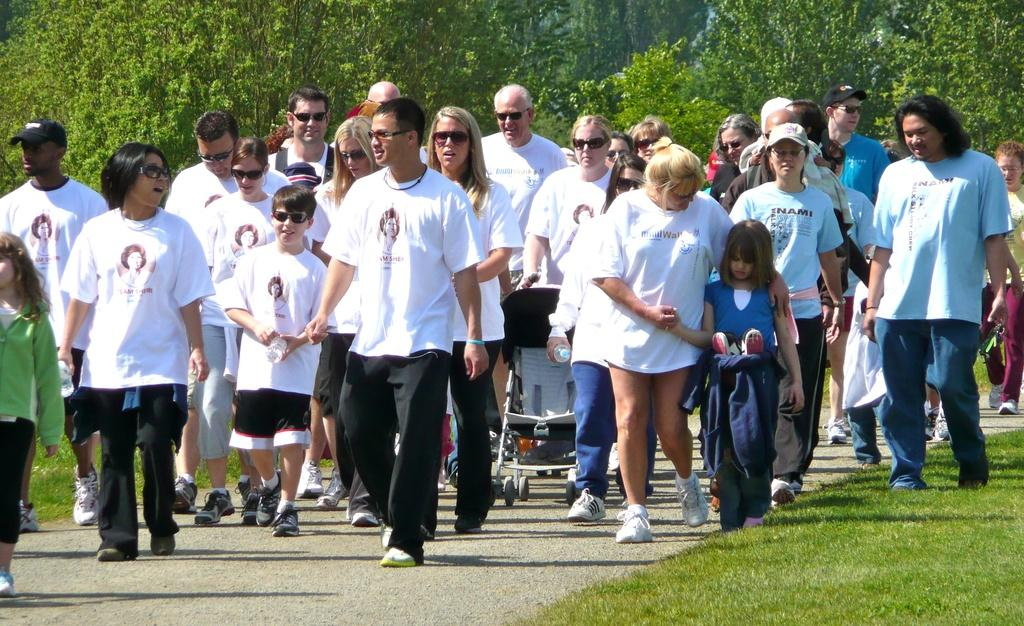What are the people in the image doing? The people in the image are walking on the road. What can be seen on the right side of the image? There is grass on the surface on the right side of the image. What is visible in the background of the image? There are trees in the background of the image. How many ladybugs can be seen crawling on the grass in the image? There are no ladybugs visible in the image; it only shows people walking on the road and grass on the right side. 